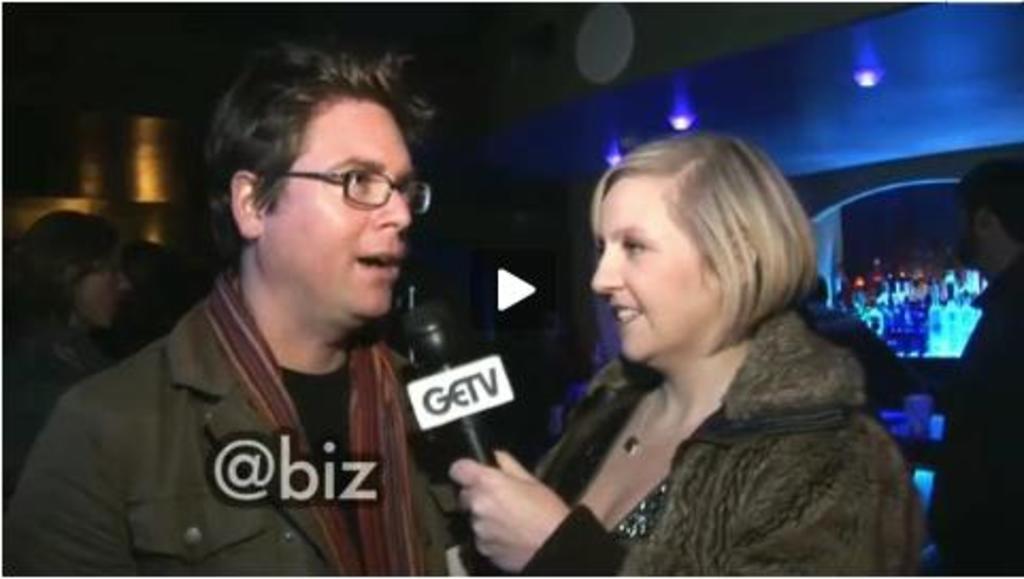Describe this image in one or two sentences. In this picture there is a man who is wearing spectacle and jacket. Beside him there is a woman who is holding a mic. In the back I can see some people who are standing near to the table. On the right I can see the wine bottles which are kept on the shelves. In the bottom left there is a watermark. 